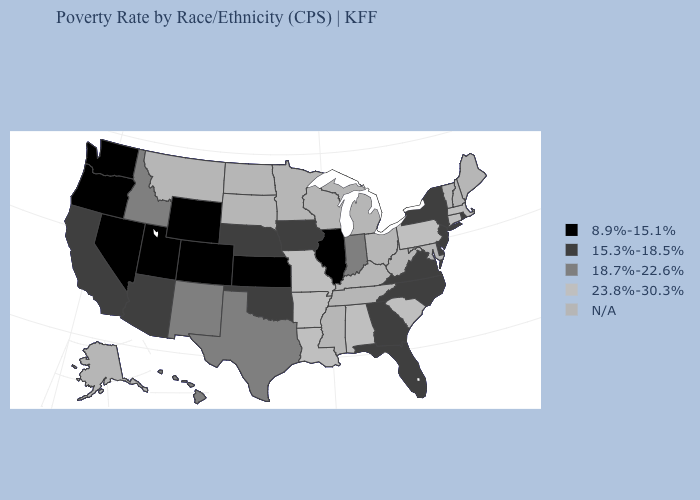Which states hav the highest value in the West?
Write a very short answer. Hawaii, Idaho, New Mexico. Name the states that have a value in the range 8.9%-15.1%?
Quick response, please. Colorado, Illinois, Kansas, Nevada, Oregon, Utah, Washington, Wyoming. Does Illinois have the lowest value in the MidWest?
Write a very short answer. Yes. Does Massachusetts have the highest value in the USA?
Be succinct. Yes. Among the states that border Washington , which have the highest value?
Write a very short answer. Idaho. Name the states that have a value in the range 18.7%-22.6%?
Be succinct. Hawaii, Idaho, Indiana, New Mexico, Texas. Name the states that have a value in the range 8.9%-15.1%?
Short answer required. Colorado, Illinois, Kansas, Nevada, Oregon, Utah, Washington, Wyoming. What is the value of North Dakota?
Give a very brief answer. N/A. Which states have the lowest value in the South?
Quick response, please. Delaware, Florida, Georgia, North Carolina, Oklahoma, Virginia. Which states have the lowest value in the USA?
Be succinct. Colorado, Illinois, Kansas, Nevada, Oregon, Utah, Washington, Wyoming. What is the highest value in states that border Vermont?
Give a very brief answer. 23.8%-30.3%. What is the value of Nebraska?
Be succinct. 15.3%-18.5%. What is the lowest value in the USA?
Write a very short answer. 8.9%-15.1%. 